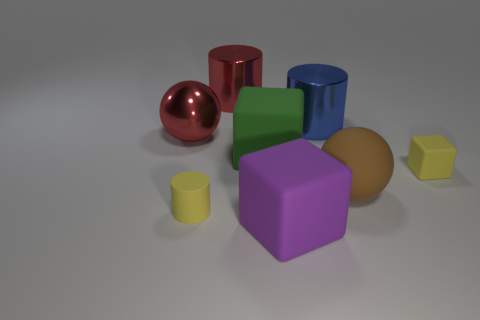Subtract all big cubes. How many cubes are left? 1 Add 1 brown matte blocks. How many objects exist? 9 Subtract 1 balls. How many balls are left? 1 Subtract all brown spheres. How many spheres are left? 1 Subtract all cylinders. How many objects are left? 5 Subtract all purple cubes. Subtract all brown cylinders. How many cubes are left? 2 Subtract all green cylinders. How many purple spheres are left? 0 Subtract all big matte cubes. Subtract all gray shiny things. How many objects are left? 6 Add 1 blue cylinders. How many blue cylinders are left? 2 Add 8 gray cylinders. How many gray cylinders exist? 8 